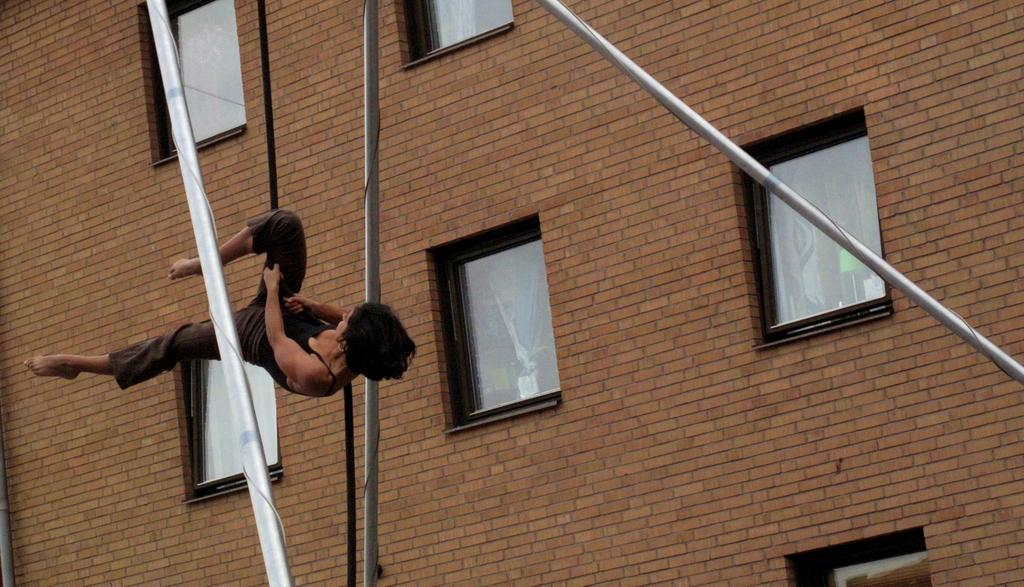What is the person in the image doing? The person is in the air, which suggests they might be climbing or performing an activity that involves being suspended. What is the person holding in the image? The person is holding a rope. What can be seen in the background of the image? There are poles and a building visible in the image. What feature of the building can be seen in the image? There are windows visible in the image. What type of push can be seen being given to the building in the image? There is no push being given to the building in the image; the person is holding a rope and appears to be engaged in an activity involving the poles. 